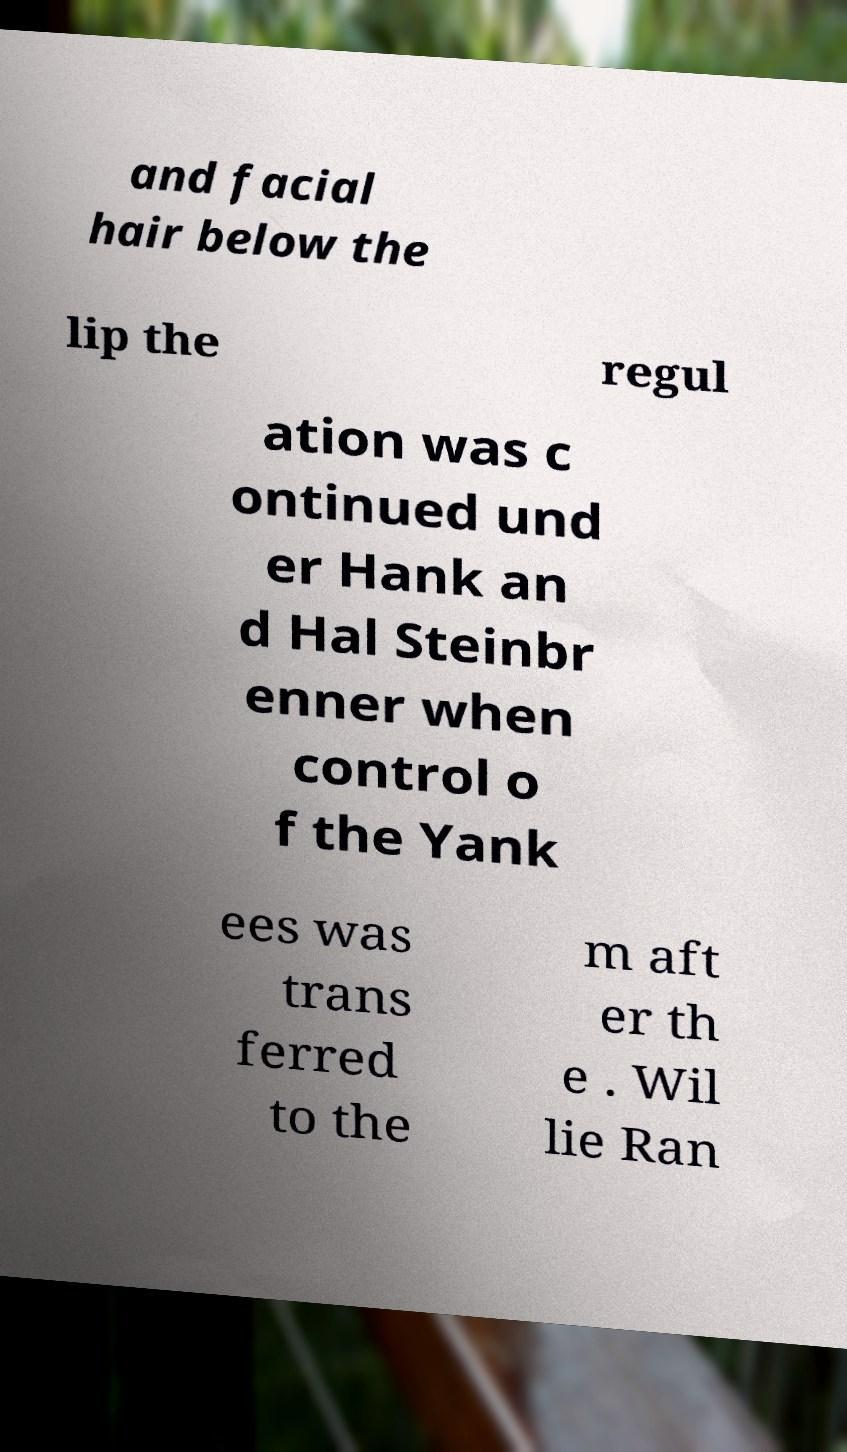For documentation purposes, I need the text within this image transcribed. Could you provide that? and facial hair below the lip the regul ation was c ontinued und er Hank an d Hal Steinbr enner when control o f the Yank ees was trans ferred to the m aft er th e . Wil lie Ran 